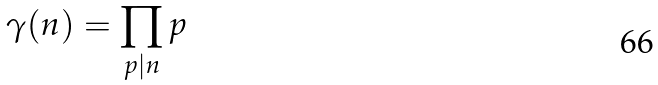Convert formula to latex. <formula><loc_0><loc_0><loc_500><loc_500>\gamma ( n ) = \prod _ { p | n } p</formula> 